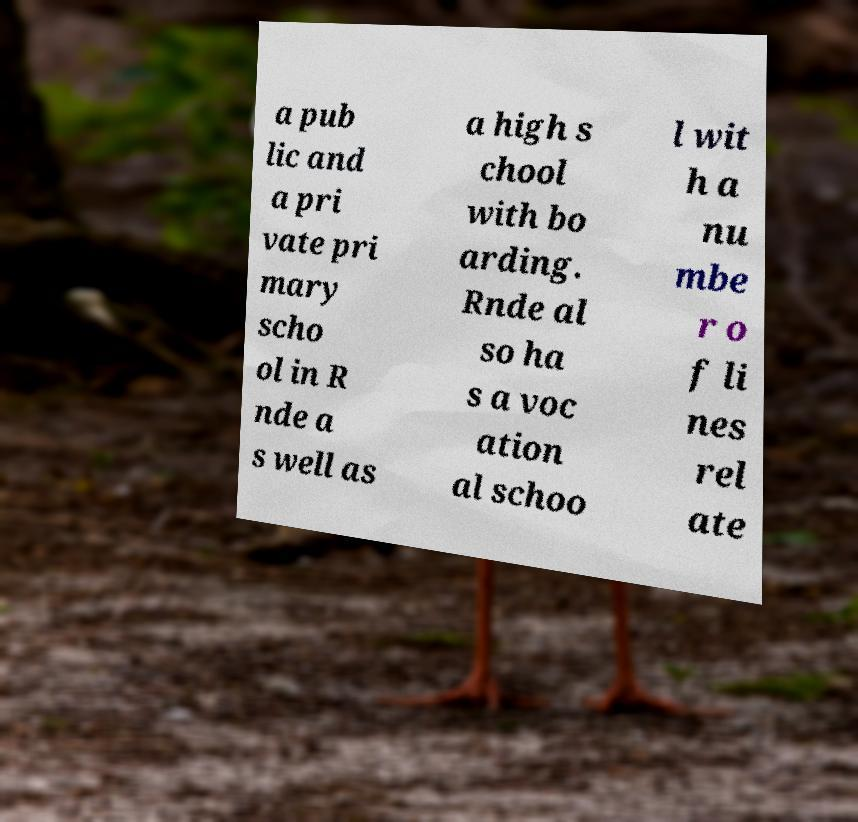There's text embedded in this image that I need extracted. Can you transcribe it verbatim? a pub lic and a pri vate pri mary scho ol in R nde a s well as a high s chool with bo arding. Rnde al so ha s a voc ation al schoo l wit h a nu mbe r o f li nes rel ate 